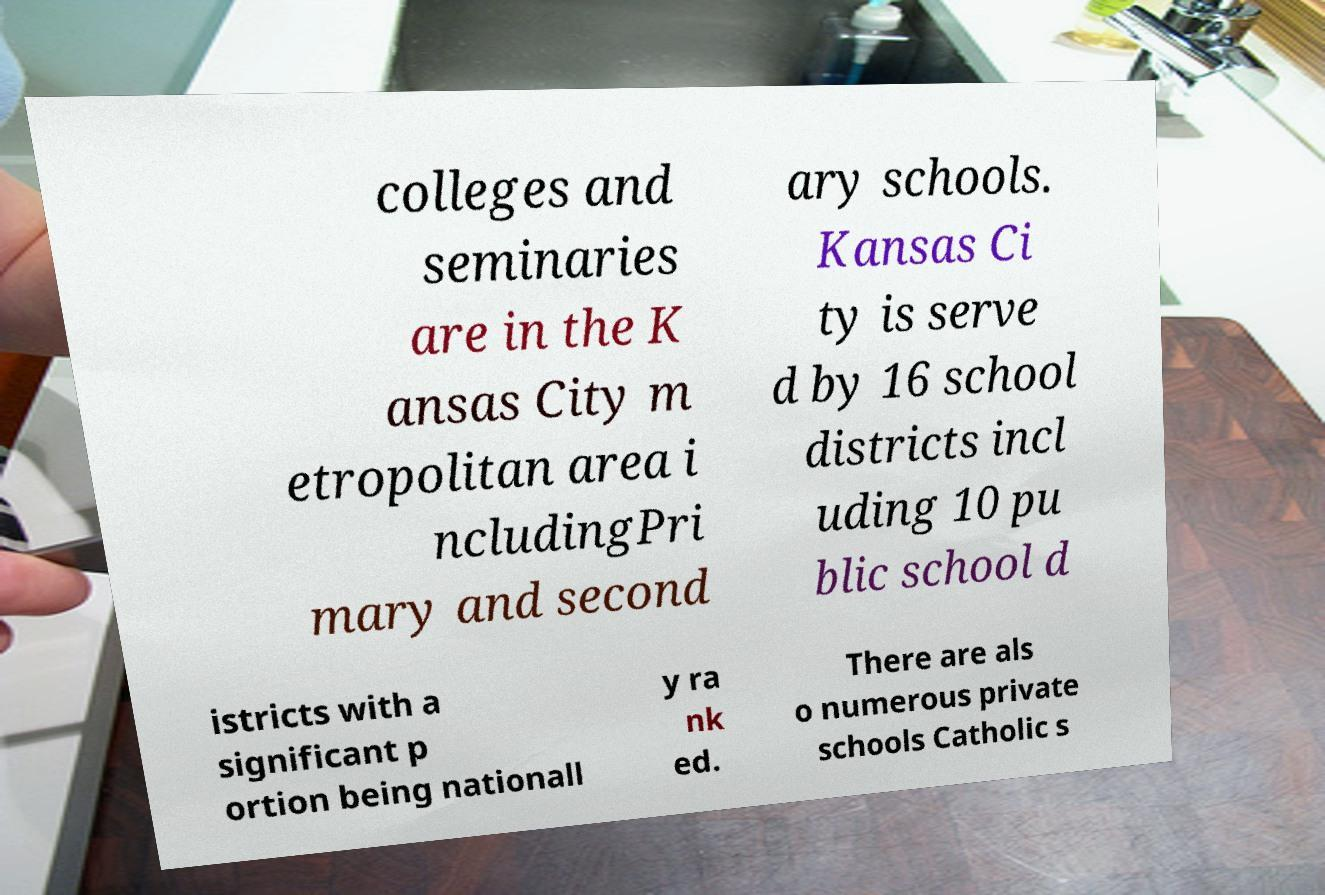I need the written content from this picture converted into text. Can you do that? colleges and seminaries are in the K ansas City m etropolitan area i ncludingPri mary and second ary schools. Kansas Ci ty is serve d by 16 school districts incl uding 10 pu blic school d istricts with a significant p ortion being nationall y ra nk ed. There are als o numerous private schools Catholic s 